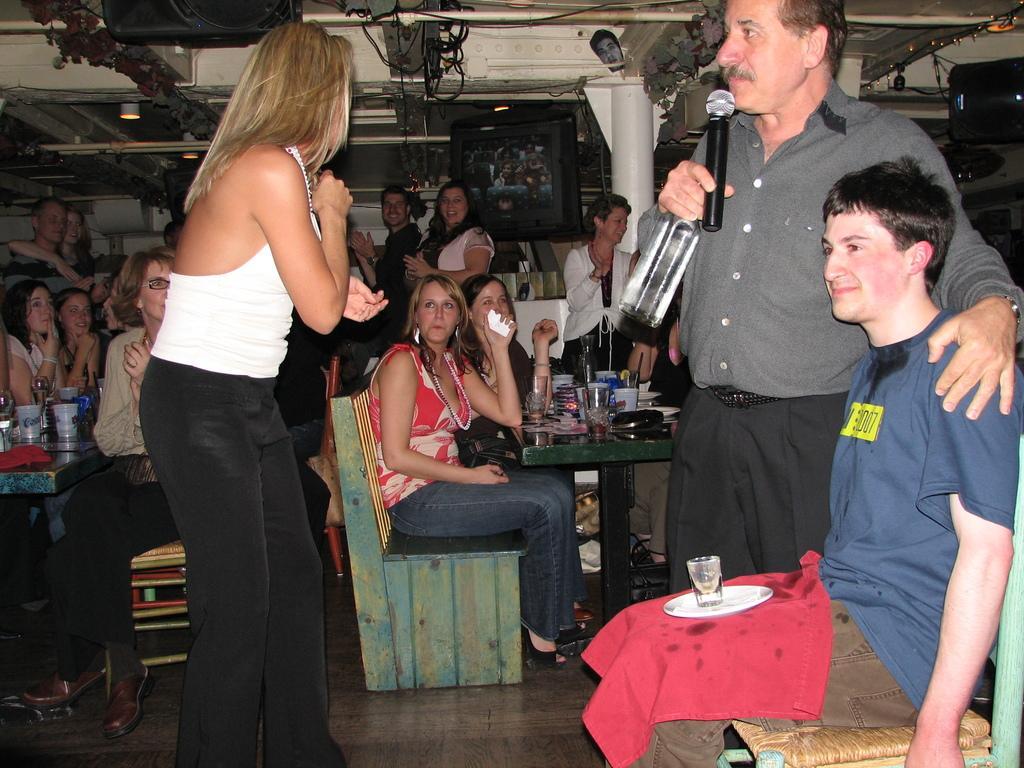Could you give a brief overview of what you see in this image? In this image we can see a person sitting on a chair keeping a plate, glass and a cloth on his lap. We can also see some people standing on the floor. In that a man is holding a bottle and a mic. On the backside we can see a group of people sitting on the chairs beside a table containing some glasses, plates and some objects on it. We can also see a pillar, a television, some devices, wires, a mask and a roof with some ceiling lights. 